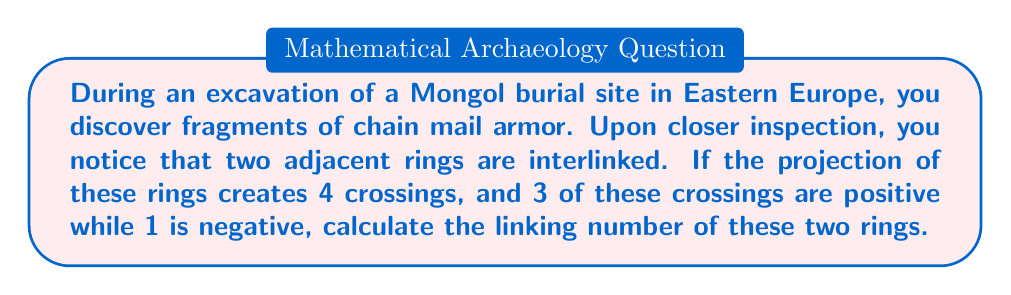Teach me how to tackle this problem. To calculate the linking number of two interlinked rings, we need to follow these steps:

1. Identify the number of crossings in the projection:
   In this case, there are 4 crossings.

2. Determine the sign of each crossing:
   We are given that 3 crossings are positive and 1 is negative.

3. Apply the linking number formula:
   The linking number (Lk) is calculated as half the sum of the crossing signs.

   Let's denote positive crossings as +1 and negative crossings as -1.

   $$Lk = \frac{1}{2} \sum (\text{crossing signs})$$

4. Sum the crossing signs:
   $$\sum (\text{crossing signs}) = (+1) + (+1) + (+1) + (-1) = +2$$

5. Calculate the linking number:
   $$Lk = \frac{1}{2} \cdot (+2) = +1$$

Therefore, the linking number of the two interlinked rings from the chain mail fragment is +1.
Answer: $+1$ 